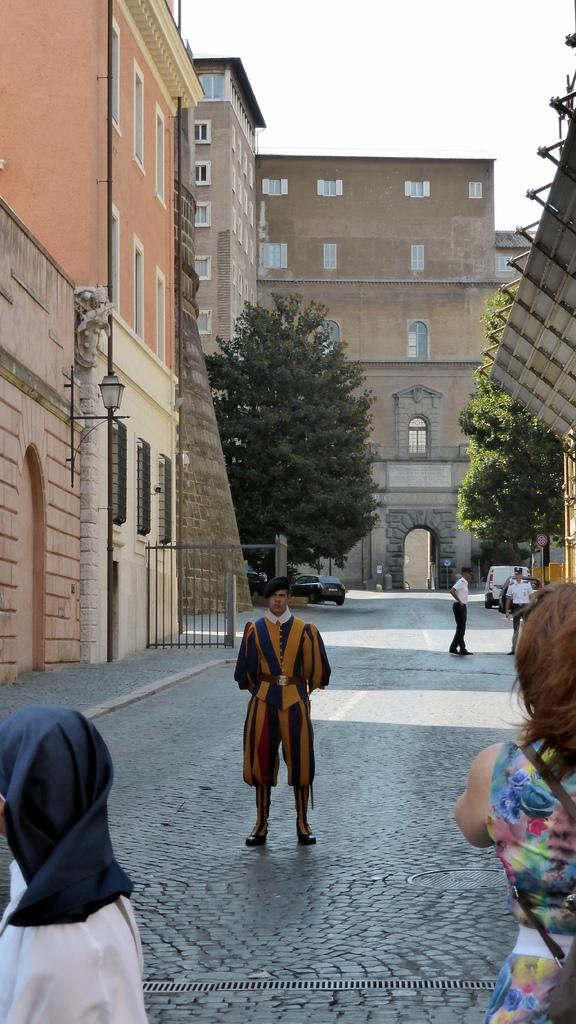What is the person in the image wearing? The person in the image is wearing a fancy dress. Where is the person located in the image? The person is standing on the street. Can you describe the group of people in the image? There is a group of people standing in the image. What type of structures can be seen in the image? There are buildings visible in the image. What other natural elements can be seen in the image? There are trees in the image. What else is present in the image besides people and buildings? There are vehicles in the image. What can be seen in the background of the image? The sky is visible in the background of the image. How many crows are sitting on the wheel in the image? There are no crows or wheels present in the image. 